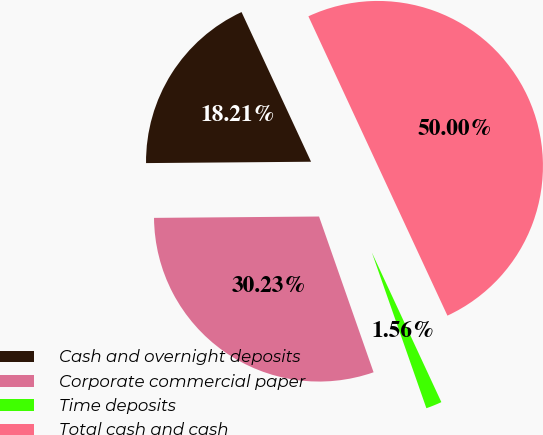Convert chart. <chart><loc_0><loc_0><loc_500><loc_500><pie_chart><fcel>Cash and overnight deposits<fcel>Corporate commercial paper<fcel>Time deposits<fcel>Total cash and cash<nl><fcel>18.21%<fcel>30.23%<fcel>1.56%<fcel>50.0%<nl></chart> 